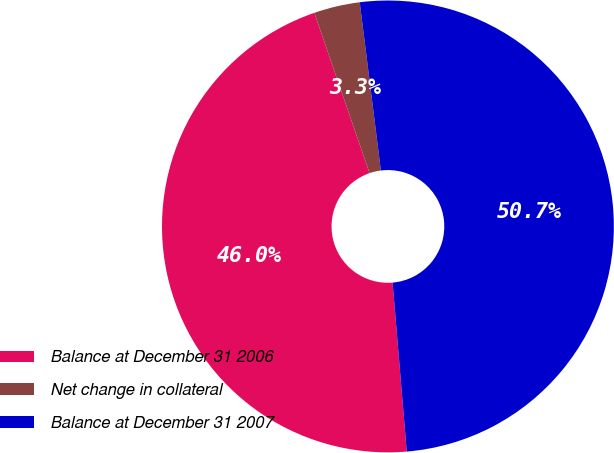<chart> <loc_0><loc_0><loc_500><loc_500><pie_chart><fcel>Balance at December 31 2006<fcel>Net change in collateral<fcel>Balance at December 31 2007<nl><fcel>46.05%<fcel>3.29%<fcel>50.66%<nl></chart> 